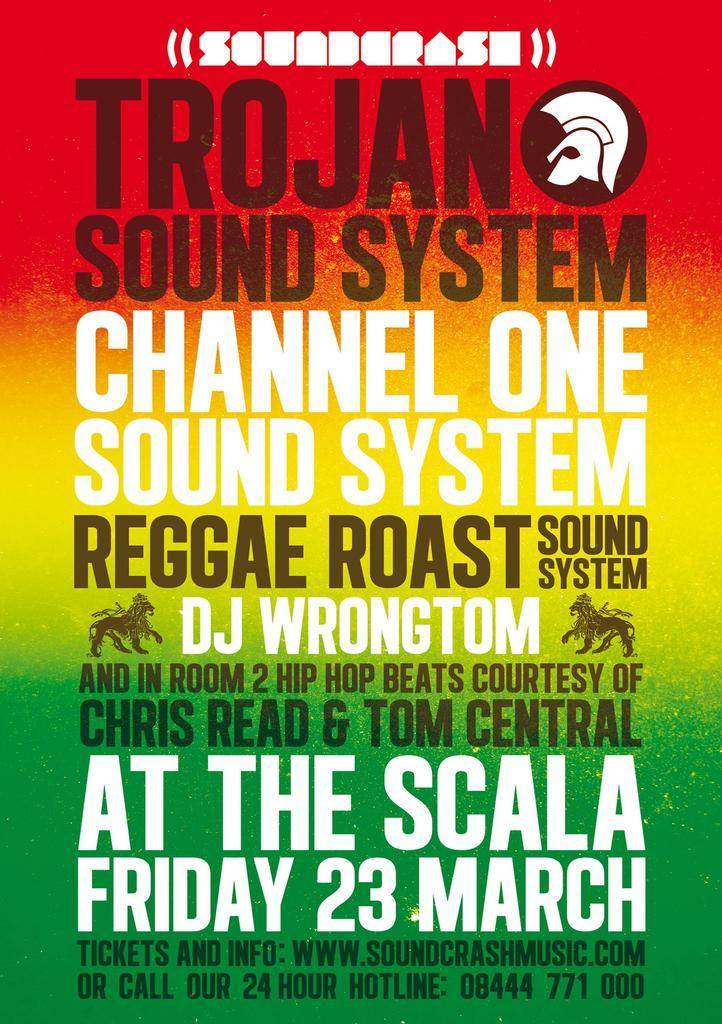<image>
Provide a brief description of the given image. Concert poster for Trojan Sound System and others. 